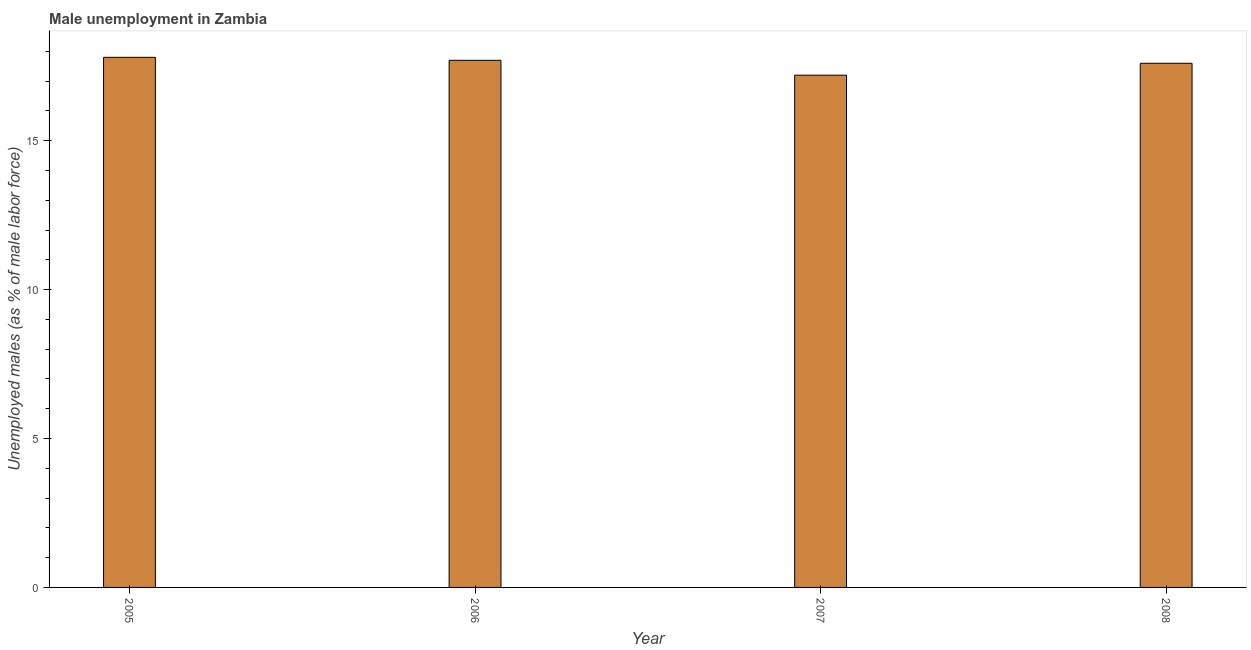Does the graph contain grids?
Offer a terse response. No. What is the title of the graph?
Your answer should be very brief. Male unemployment in Zambia. What is the label or title of the X-axis?
Offer a very short reply. Year. What is the label or title of the Y-axis?
Provide a short and direct response. Unemployed males (as % of male labor force). What is the unemployed males population in 2006?
Keep it short and to the point. 17.7. Across all years, what is the maximum unemployed males population?
Your response must be concise. 17.8. Across all years, what is the minimum unemployed males population?
Keep it short and to the point. 17.2. What is the sum of the unemployed males population?
Keep it short and to the point. 70.3. What is the average unemployed males population per year?
Your answer should be very brief. 17.57. What is the median unemployed males population?
Offer a very short reply. 17.65. In how many years, is the unemployed males population greater than 13 %?
Provide a short and direct response. 4. Is the difference between the unemployed males population in 2005 and 2007 greater than the difference between any two years?
Provide a succinct answer. Yes. What is the difference between the highest and the second highest unemployed males population?
Keep it short and to the point. 0.1. Is the sum of the unemployed males population in 2005 and 2007 greater than the maximum unemployed males population across all years?
Offer a very short reply. Yes. What is the difference between the highest and the lowest unemployed males population?
Give a very brief answer. 0.6. How many bars are there?
Provide a succinct answer. 4. Are the values on the major ticks of Y-axis written in scientific E-notation?
Give a very brief answer. No. What is the Unemployed males (as % of male labor force) of 2005?
Give a very brief answer. 17.8. What is the Unemployed males (as % of male labor force) in 2006?
Offer a terse response. 17.7. What is the Unemployed males (as % of male labor force) in 2007?
Make the answer very short. 17.2. What is the Unemployed males (as % of male labor force) in 2008?
Provide a short and direct response. 17.6. What is the difference between the Unemployed males (as % of male labor force) in 2005 and 2007?
Your response must be concise. 0.6. What is the difference between the Unemployed males (as % of male labor force) in 2006 and 2008?
Your response must be concise. 0.1. What is the difference between the Unemployed males (as % of male labor force) in 2007 and 2008?
Keep it short and to the point. -0.4. What is the ratio of the Unemployed males (as % of male labor force) in 2005 to that in 2006?
Your answer should be compact. 1.01. What is the ratio of the Unemployed males (as % of male labor force) in 2005 to that in 2007?
Keep it short and to the point. 1.03. What is the ratio of the Unemployed males (as % of male labor force) in 2006 to that in 2007?
Make the answer very short. 1.03. What is the ratio of the Unemployed males (as % of male labor force) in 2006 to that in 2008?
Your answer should be very brief. 1.01. 